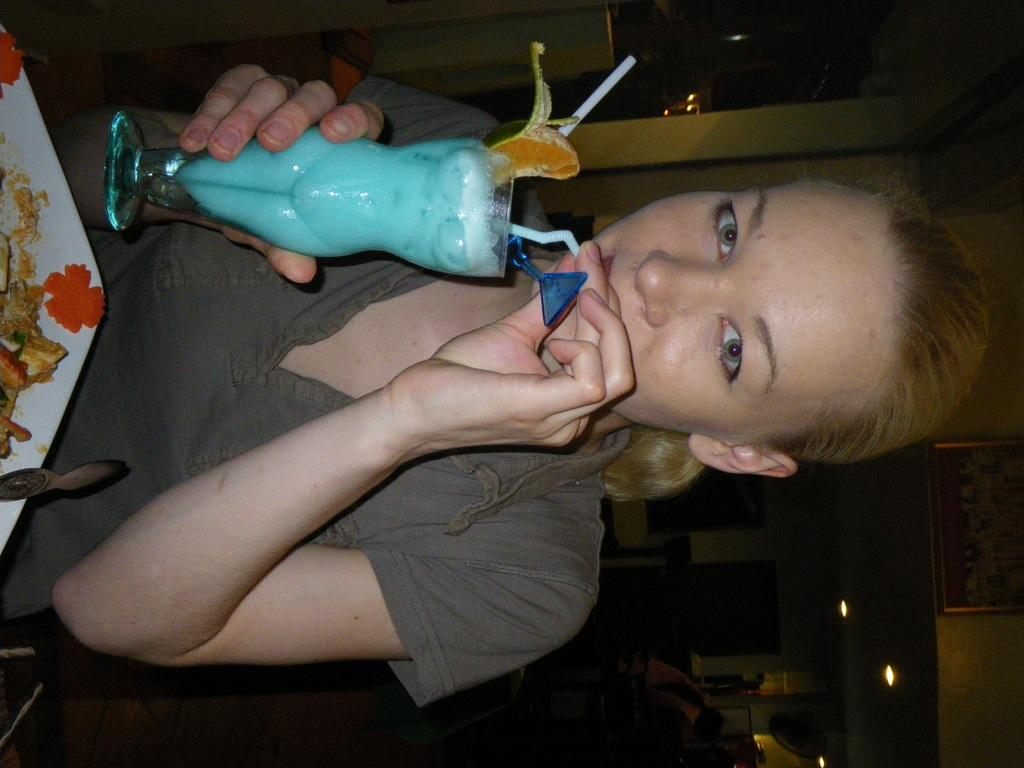Who is present in the image? There is a lady in the image. What is the lady holding in the image? The lady is holding a glass. What is the lady doing with the glass? The lady is drinking juice from the glass. What color is the top that the lady is wearing? The lady is wearing a grey color top. What is located in front of the lady? There is a food dish in front of the lady. What utensil is associated with the food dish? There is a spoon associated with the food dish. How many mountains can be seen in the image? There are no mountains present in the image. Is there a bridge visible in the image? There is no bridge present in the image. 